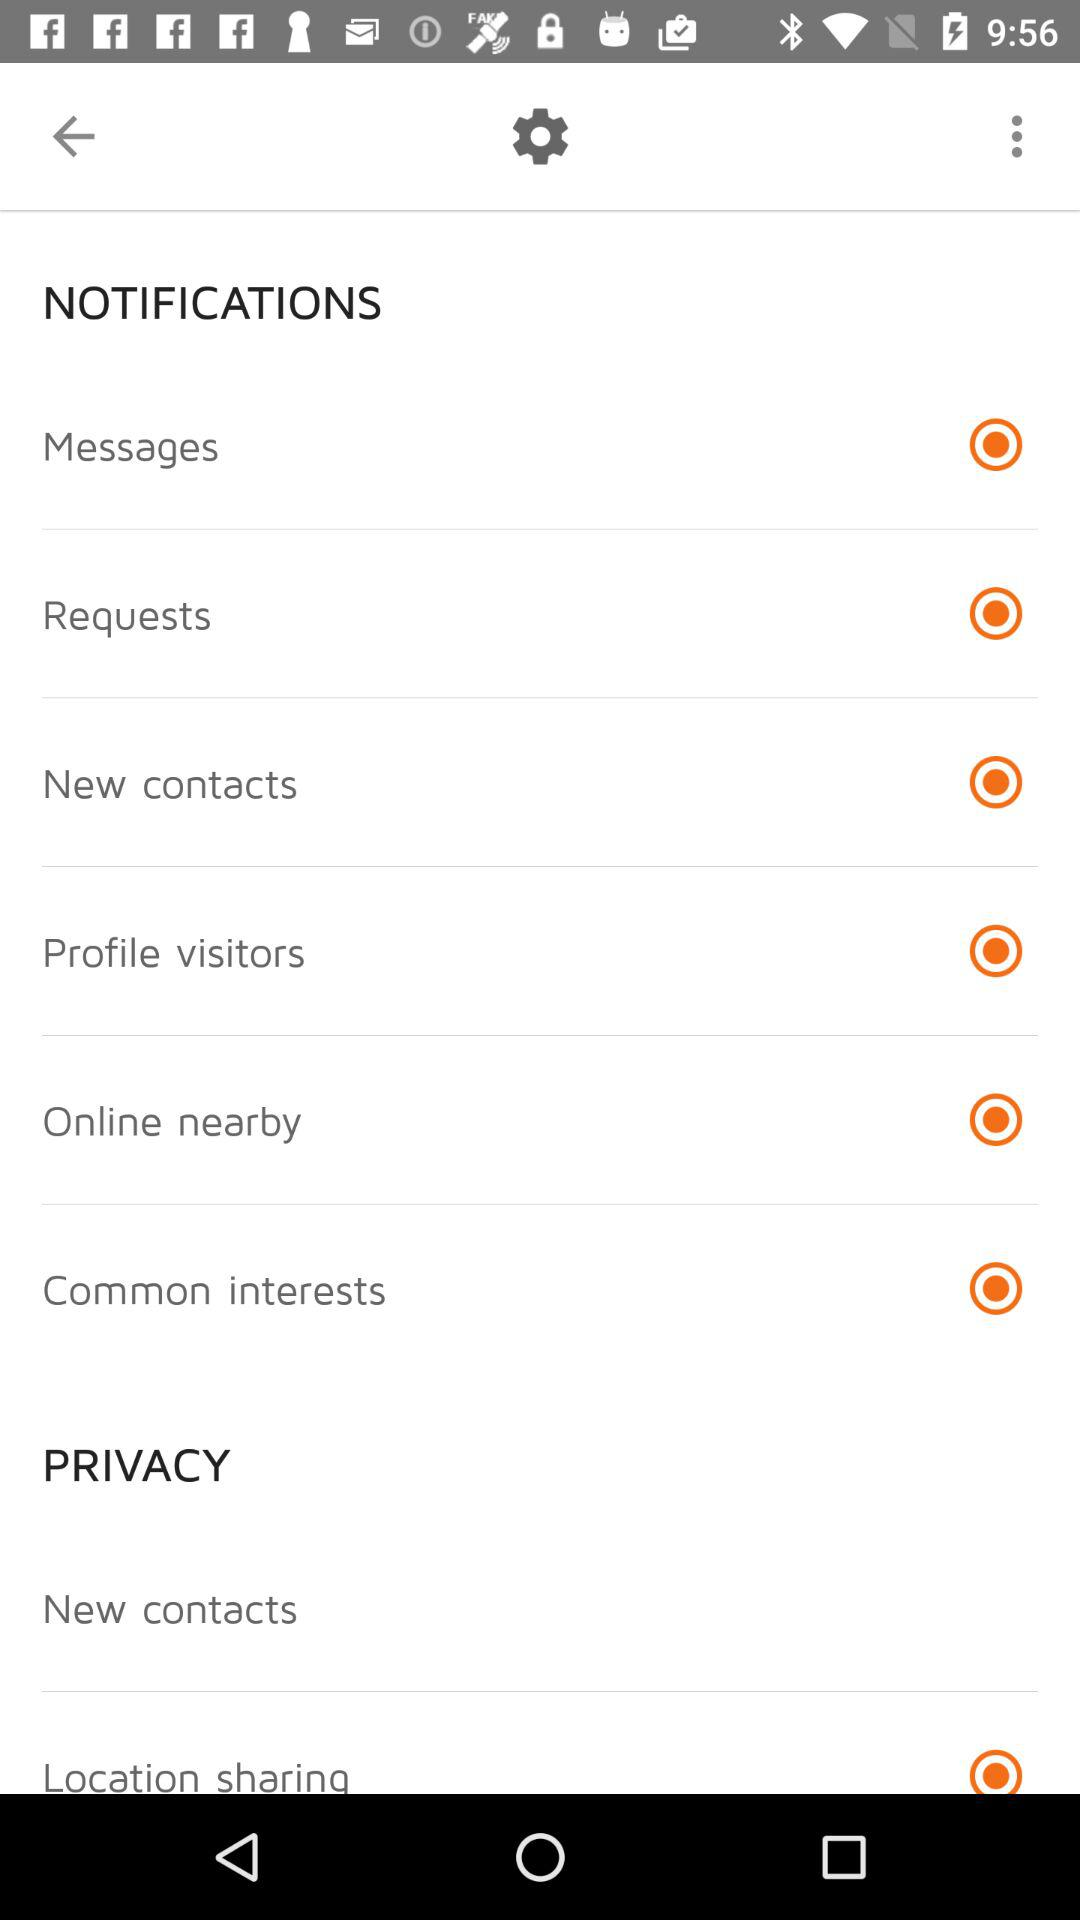Is "Location sharing" selected or not selected? "Location sharing" is selected. 